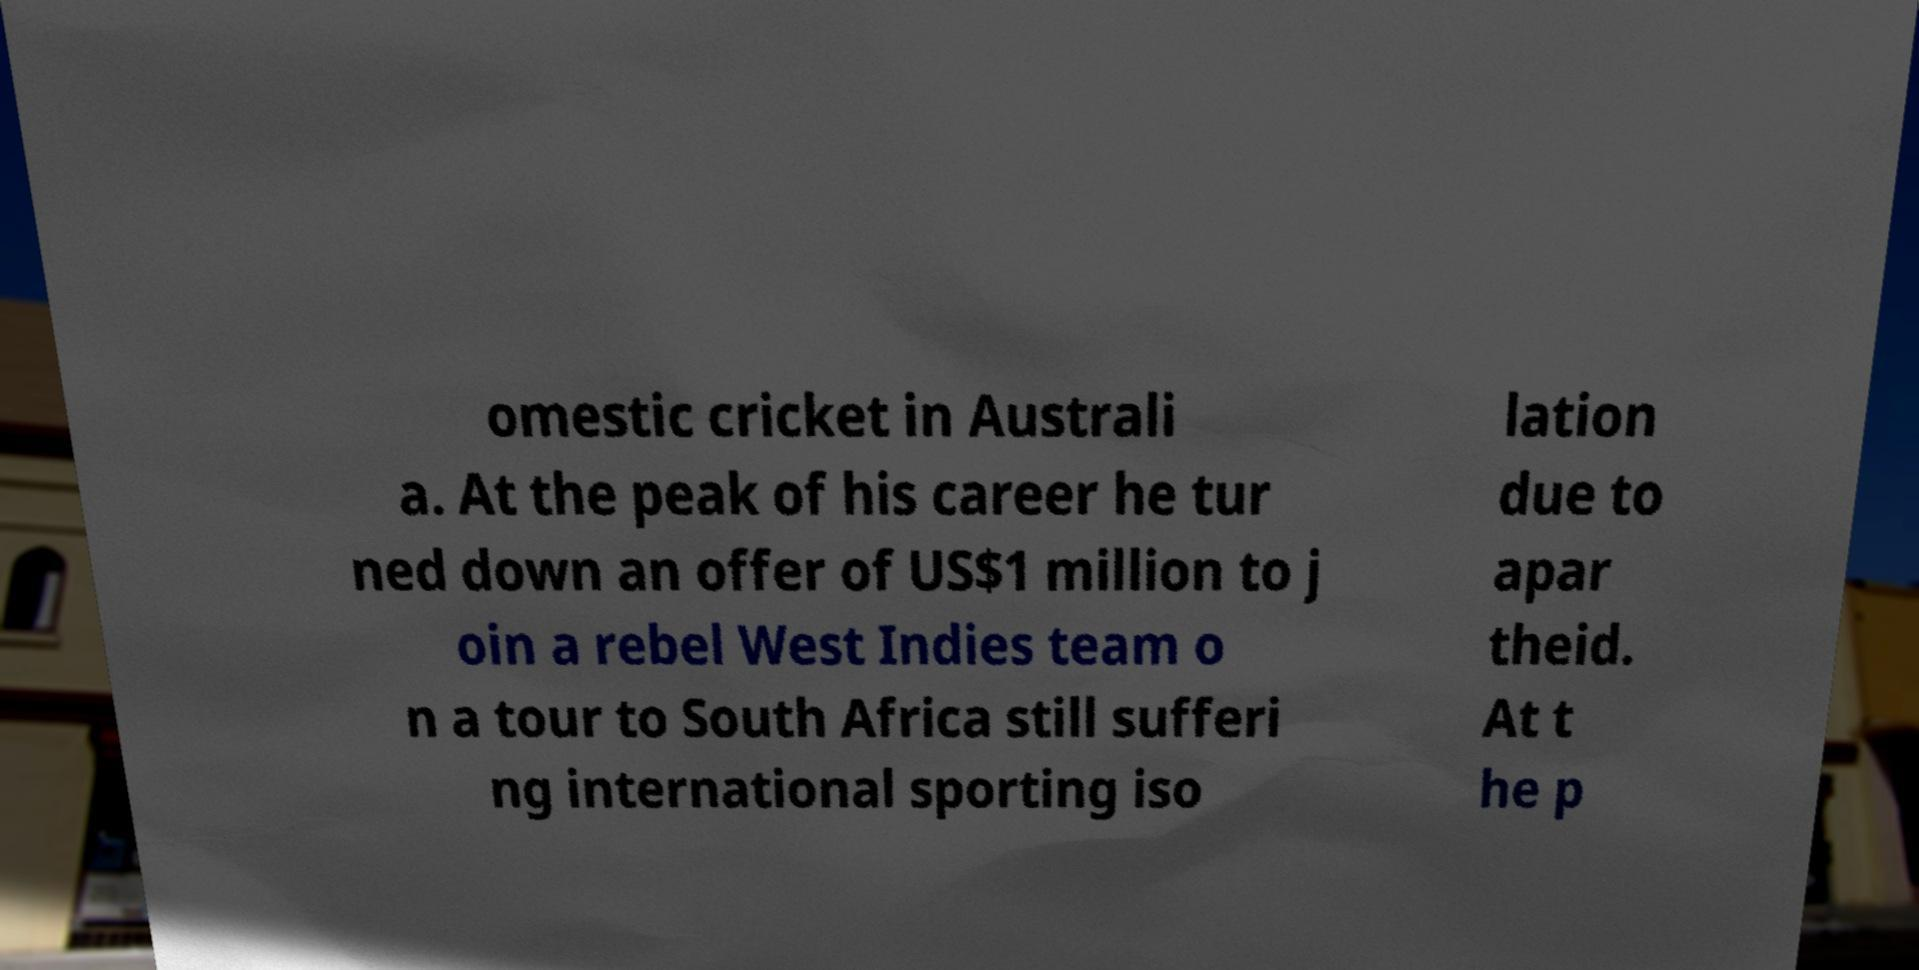Please identify and transcribe the text found in this image. omestic cricket in Australi a. At the peak of his career he tur ned down an offer of US$1 million to j oin a rebel West Indies team o n a tour to South Africa still sufferi ng international sporting iso lation due to apar theid. At t he p 